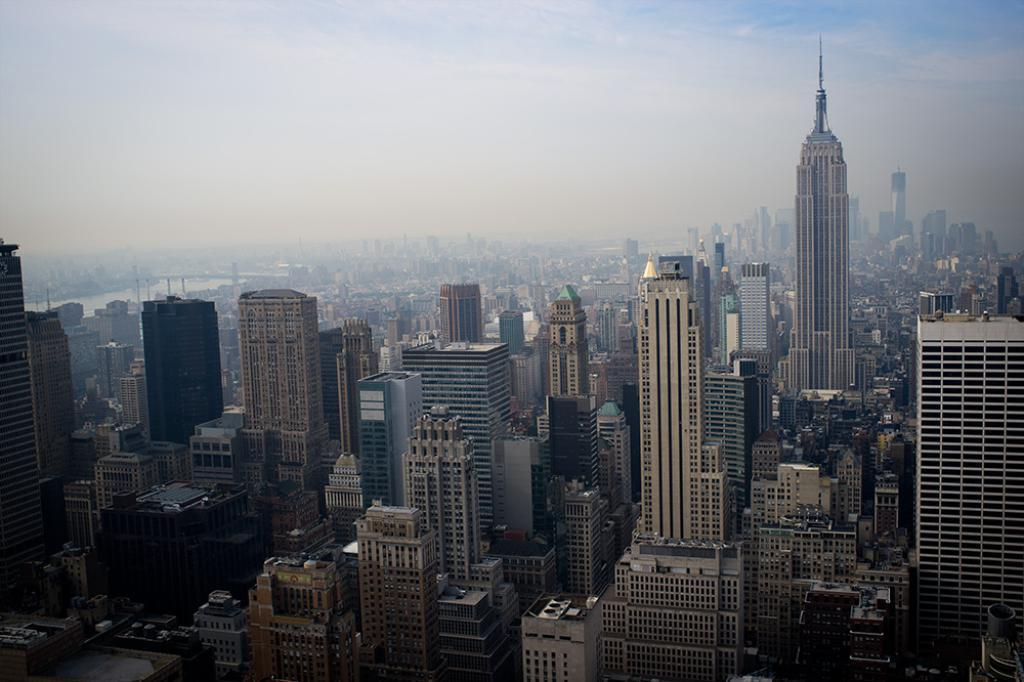What type of structures are located at the bottom of the image? There are buildings at the bottom of the image. What can be seen in the sky at the top of the image? There are clouds in the sky at the top of the image. How many frogs are jumping on the zipper of the pocket in the image? There are no frogs, zippers, or pockets present in the image. 